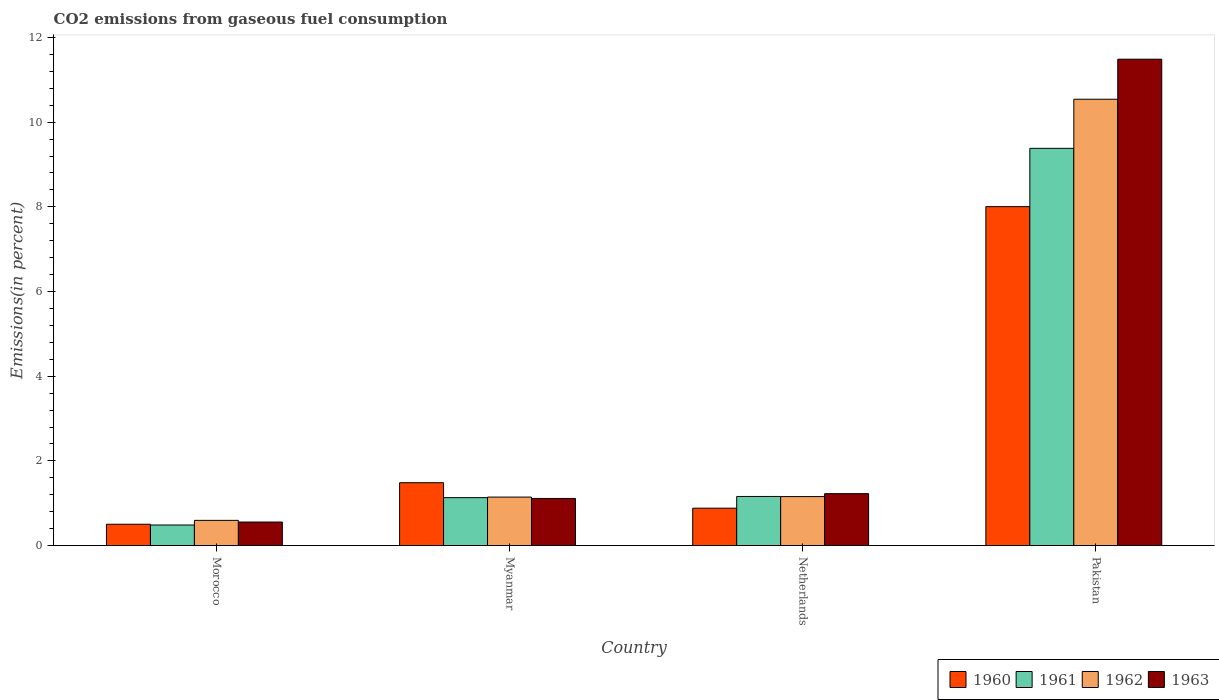How many different coloured bars are there?
Keep it short and to the point. 4. Are the number of bars per tick equal to the number of legend labels?
Keep it short and to the point. Yes. In how many cases, is the number of bars for a given country not equal to the number of legend labels?
Offer a very short reply. 0. What is the total CO2 emitted in 1962 in Pakistan?
Keep it short and to the point. 10.54. Across all countries, what is the maximum total CO2 emitted in 1963?
Give a very brief answer. 11.49. Across all countries, what is the minimum total CO2 emitted in 1963?
Offer a terse response. 0.56. In which country was the total CO2 emitted in 1960 maximum?
Offer a very short reply. Pakistan. In which country was the total CO2 emitted in 1960 minimum?
Your answer should be very brief. Morocco. What is the total total CO2 emitted in 1962 in the graph?
Your response must be concise. 13.44. What is the difference between the total CO2 emitted in 1960 in Myanmar and that in Netherlands?
Offer a very short reply. 0.6. What is the difference between the total CO2 emitted in 1961 in Myanmar and the total CO2 emitted in 1962 in Netherlands?
Ensure brevity in your answer.  -0.03. What is the average total CO2 emitted in 1963 per country?
Your answer should be compact. 3.6. What is the difference between the total CO2 emitted of/in 1962 and total CO2 emitted of/in 1960 in Morocco?
Provide a succinct answer. 0.09. In how many countries, is the total CO2 emitted in 1961 greater than 3.2 %?
Your response must be concise. 1. What is the ratio of the total CO2 emitted in 1962 in Morocco to that in Pakistan?
Offer a terse response. 0.06. Is the total CO2 emitted in 1960 in Myanmar less than that in Netherlands?
Your answer should be compact. No. Is the difference between the total CO2 emitted in 1962 in Myanmar and Netherlands greater than the difference between the total CO2 emitted in 1960 in Myanmar and Netherlands?
Provide a short and direct response. No. What is the difference between the highest and the second highest total CO2 emitted in 1961?
Ensure brevity in your answer.  8.25. What is the difference between the highest and the lowest total CO2 emitted in 1962?
Your answer should be very brief. 9.95. In how many countries, is the total CO2 emitted in 1962 greater than the average total CO2 emitted in 1962 taken over all countries?
Your response must be concise. 1. Is it the case that in every country, the sum of the total CO2 emitted in 1962 and total CO2 emitted in 1963 is greater than the total CO2 emitted in 1961?
Your answer should be compact. Yes. How many countries are there in the graph?
Provide a short and direct response. 4. Are the values on the major ticks of Y-axis written in scientific E-notation?
Provide a short and direct response. No. Where does the legend appear in the graph?
Offer a terse response. Bottom right. How are the legend labels stacked?
Your answer should be compact. Horizontal. What is the title of the graph?
Make the answer very short. CO2 emissions from gaseous fuel consumption. Does "1972" appear as one of the legend labels in the graph?
Ensure brevity in your answer.  No. What is the label or title of the X-axis?
Your response must be concise. Country. What is the label or title of the Y-axis?
Ensure brevity in your answer.  Emissions(in percent). What is the Emissions(in percent) in 1960 in Morocco?
Your response must be concise. 0.5. What is the Emissions(in percent) of 1961 in Morocco?
Keep it short and to the point. 0.49. What is the Emissions(in percent) in 1962 in Morocco?
Your response must be concise. 0.6. What is the Emissions(in percent) of 1963 in Morocco?
Make the answer very short. 0.56. What is the Emissions(in percent) in 1960 in Myanmar?
Ensure brevity in your answer.  1.48. What is the Emissions(in percent) of 1961 in Myanmar?
Keep it short and to the point. 1.13. What is the Emissions(in percent) in 1962 in Myanmar?
Offer a terse response. 1.15. What is the Emissions(in percent) in 1963 in Myanmar?
Offer a very short reply. 1.11. What is the Emissions(in percent) of 1960 in Netherlands?
Provide a short and direct response. 0.88. What is the Emissions(in percent) in 1961 in Netherlands?
Provide a succinct answer. 1.16. What is the Emissions(in percent) in 1962 in Netherlands?
Make the answer very short. 1.16. What is the Emissions(in percent) of 1963 in Netherlands?
Provide a short and direct response. 1.23. What is the Emissions(in percent) of 1960 in Pakistan?
Your answer should be compact. 8.01. What is the Emissions(in percent) in 1961 in Pakistan?
Offer a terse response. 9.38. What is the Emissions(in percent) of 1962 in Pakistan?
Your answer should be very brief. 10.54. What is the Emissions(in percent) of 1963 in Pakistan?
Offer a very short reply. 11.49. Across all countries, what is the maximum Emissions(in percent) of 1960?
Your response must be concise. 8.01. Across all countries, what is the maximum Emissions(in percent) in 1961?
Offer a terse response. 9.38. Across all countries, what is the maximum Emissions(in percent) in 1962?
Provide a short and direct response. 10.54. Across all countries, what is the maximum Emissions(in percent) of 1963?
Keep it short and to the point. 11.49. Across all countries, what is the minimum Emissions(in percent) in 1960?
Keep it short and to the point. 0.5. Across all countries, what is the minimum Emissions(in percent) in 1961?
Offer a very short reply. 0.49. Across all countries, what is the minimum Emissions(in percent) in 1962?
Your answer should be compact. 0.6. Across all countries, what is the minimum Emissions(in percent) of 1963?
Your response must be concise. 0.56. What is the total Emissions(in percent) in 1960 in the graph?
Your answer should be very brief. 10.88. What is the total Emissions(in percent) in 1961 in the graph?
Your answer should be very brief. 12.16. What is the total Emissions(in percent) in 1962 in the graph?
Keep it short and to the point. 13.44. What is the total Emissions(in percent) of 1963 in the graph?
Give a very brief answer. 14.38. What is the difference between the Emissions(in percent) in 1960 in Morocco and that in Myanmar?
Make the answer very short. -0.98. What is the difference between the Emissions(in percent) of 1961 in Morocco and that in Myanmar?
Provide a short and direct response. -0.65. What is the difference between the Emissions(in percent) in 1962 in Morocco and that in Myanmar?
Your answer should be very brief. -0.55. What is the difference between the Emissions(in percent) of 1963 in Morocco and that in Myanmar?
Make the answer very short. -0.56. What is the difference between the Emissions(in percent) in 1960 in Morocco and that in Netherlands?
Make the answer very short. -0.38. What is the difference between the Emissions(in percent) in 1961 in Morocco and that in Netherlands?
Provide a short and direct response. -0.67. What is the difference between the Emissions(in percent) in 1962 in Morocco and that in Netherlands?
Keep it short and to the point. -0.56. What is the difference between the Emissions(in percent) of 1963 in Morocco and that in Netherlands?
Your answer should be very brief. -0.67. What is the difference between the Emissions(in percent) of 1960 in Morocco and that in Pakistan?
Your answer should be very brief. -7.5. What is the difference between the Emissions(in percent) in 1961 in Morocco and that in Pakistan?
Provide a succinct answer. -8.9. What is the difference between the Emissions(in percent) of 1962 in Morocco and that in Pakistan?
Provide a short and direct response. -9.95. What is the difference between the Emissions(in percent) of 1963 in Morocco and that in Pakistan?
Make the answer very short. -10.93. What is the difference between the Emissions(in percent) of 1960 in Myanmar and that in Netherlands?
Offer a terse response. 0.6. What is the difference between the Emissions(in percent) in 1961 in Myanmar and that in Netherlands?
Offer a very short reply. -0.03. What is the difference between the Emissions(in percent) of 1962 in Myanmar and that in Netherlands?
Your answer should be compact. -0.01. What is the difference between the Emissions(in percent) of 1963 in Myanmar and that in Netherlands?
Your response must be concise. -0.11. What is the difference between the Emissions(in percent) of 1960 in Myanmar and that in Pakistan?
Make the answer very short. -6.52. What is the difference between the Emissions(in percent) of 1961 in Myanmar and that in Pakistan?
Your response must be concise. -8.25. What is the difference between the Emissions(in percent) in 1962 in Myanmar and that in Pakistan?
Make the answer very short. -9.4. What is the difference between the Emissions(in percent) of 1963 in Myanmar and that in Pakistan?
Your response must be concise. -10.37. What is the difference between the Emissions(in percent) in 1960 in Netherlands and that in Pakistan?
Offer a terse response. -7.12. What is the difference between the Emissions(in percent) of 1961 in Netherlands and that in Pakistan?
Your response must be concise. -8.22. What is the difference between the Emissions(in percent) in 1962 in Netherlands and that in Pakistan?
Give a very brief answer. -9.38. What is the difference between the Emissions(in percent) of 1963 in Netherlands and that in Pakistan?
Make the answer very short. -10.26. What is the difference between the Emissions(in percent) of 1960 in Morocco and the Emissions(in percent) of 1961 in Myanmar?
Make the answer very short. -0.63. What is the difference between the Emissions(in percent) of 1960 in Morocco and the Emissions(in percent) of 1962 in Myanmar?
Ensure brevity in your answer.  -0.64. What is the difference between the Emissions(in percent) of 1960 in Morocco and the Emissions(in percent) of 1963 in Myanmar?
Provide a succinct answer. -0.61. What is the difference between the Emissions(in percent) of 1961 in Morocco and the Emissions(in percent) of 1962 in Myanmar?
Your answer should be very brief. -0.66. What is the difference between the Emissions(in percent) in 1961 in Morocco and the Emissions(in percent) in 1963 in Myanmar?
Offer a terse response. -0.63. What is the difference between the Emissions(in percent) of 1962 in Morocco and the Emissions(in percent) of 1963 in Myanmar?
Make the answer very short. -0.52. What is the difference between the Emissions(in percent) in 1960 in Morocco and the Emissions(in percent) in 1961 in Netherlands?
Provide a succinct answer. -0.66. What is the difference between the Emissions(in percent) in 1960 in Morocco and the Emissions(in percent) in 1962 in Netherlands?
Provide a succinct answer. -0.65. What is the difference between the Emissions(in percent) in 1960 in Morocco and the Emissions(in percent) in 1963 in Netherlands?
Your answer should be compact. -0.72. What is the difference between the Emissions(in percent) in 1961 in Morocco and the Emissions(in percent) in 1962 in Netherlands?
Your answer should be very brief. -0.67. What is the difference between the Emissions(in percent) of 1961 in Morocco and the Emissions(in percent) of 1963 in Netherlands?
Keep it short and to the point. -0.74. What is the difference between the Emissions(in percent) of 1962 in Morocco and the Emissions(in percent) of 1963 in Netherlands?
Give a very brief answer. -0.63. What is the difference between the Emissions(in percent) of 1960 in Morocco and the Emissions(in percent) of 1961 in Pakistan?
Provide a short and direct response. -8.88. What is the difference between the Emissions(in percent) in 1960 in Morocco and the Emissions(in percent) in 1962 in Pakistan?
Give a very brief answer. -10.04. What is the difference between the Emissions(in percent) in 1960 in Morocco and the Emissions(in percent) in 1963 in Pakistan?
Your answer should be very brief. -10.98. What is the difference between the Emissions(in percent) in 1961 in Morocco and the Emissions(in percent) in 1962 in Pakistan?
Provide a succinct answer. -10.06. What is the difference between the Emissions(in percent) of 1961 in Morocco and the Emissions(in percent) of 1963 in Pakistan?
Offer a very short reply. -11. What is the difference between the Emissions(in percent) of 1962 in Morocco and the Emissions(in percent) of 1963 in Pakistan?
Offer a terse response. -10.89. What is the difference between the Emissions(in percent) in 1960 in Myanmar and the Emissions(in percent) in 1961 in Netherlands?
Provide a short and direct response. 0.32. What is the difference between the Emissions(in percent) of 1960 in Myanmar and the Emissions(in percent) of 1962 in Netherlands?
Your response must be concise. 0.33. What is the difference between the Emissions(in percent) in 1960 in Myanmar and the Emissions(in percent) in 1963 in Netherlands?
Give a very brief answer. 0.26. What is the difference between the Emissions(in percent) of 1961 in Myanmar and the Emissions(in percent) of 1962 in Netherlands?
Offer a terse response. -0.03. What is the difference between the Emissions(in percent) in 1961 in Myanmar and the Emissions(in percent) in 1963 in Netherlands?
Your response must be concise. -0.09. What is the difference between the Emissions(in percent) of 1962 in Myanmar and the Emissions(in percent) of 1963 in Netherlands?
Your answer should be compact. -0.08. What is the difference between the Emissions(in percent) of 1960 in Myanmar and the Emissions(in percent) of 1961 in Pakistan?
Provide a succinct answer. -7.9. What is the difference between the Emissions(in percent) of 1960 in Myanmar and the Emissions(in percent) of 1962 in Pakistan?
Provide a succinct answer. -9.06. What is the difference between the Emissions(in percent) of 1960 in Myanmar and the Emissions(in percent) of 1963 in Pakistan?
Offer a very short reply. -10. What is the difference between the Emissions(in percent) of 1961 in Myanmar and the Emissions(in percent) of 1962 in Pakistan?
Ensure brevity in your answer.  -9.41. What is the difference between the Emissions(in percent) of 1961 in Myanmar and the Emissions(in percent) of 1963 in Pakistan?
Provide a short and direct response. -10.36. What is the difference between the Emissions(in percent) of 1962 in Myanmar and the Emissions(in percent) of 1963 in Pakistan?
Offer a terse response. -10.34. What is the difference between the Emissions(in percent) in 1960 in Netherlands and the Emissions(in percent) in 1961 in Pakistan?
Keep it short and to the point. -8.5. What is the difference between the Emissions(in percent) in 1960 in Netherlands and the Emissions(in percent) in 1962 in Pakistan?
Offer a very short reply. -9.66. What is the difference between the Emissions(in percent) of 1960 in Netherlands and the Emissions(in percent) of 1963 in Pakistan?
Offer a terse response. -10.6. What is the difference between the Emissions(in percent) of 1961 in Netherlands and the Emissions(in percent) of 1962 in Pakistan?
Your answer should be compact. -9.38. What is the difference between the Emissions(in percent) of 1961 in Netherlands and the Emissions(in percent) of 1963 in Pakistan?
Make the answer very short. -10.33. What is the difference between the Emissions(in percent) in 1962 in Netherlands and the Emissions(in percent) in 1963 in Pakistan?
Keep it short and to the point. -10.33. What is the average Emissions(in percent) of 1960 per country?
Keep it short and to the point. 2.72. What is the average Emissions(in percent) of 1961 per country?
Give a very brief answer. 3.04. What is the average Emissions(in percent) of 1962 per country?
Provide a succinct answer. 3.36. What is the average Emissions(in percent) in 1963 per country?
Make the answer very short. 3.6. What is the difference between the Emissions(in percent) in 1960 and Emissions(in percent) in 1961 in Morocco?
Make the answer very short. 0.02. What is the difference between the Emissions(in percent) in 1960 and Emissions(in percent) in 1962 in Morocco?
Your answer should be compact. -0.09. What is the difference between the Emissions(in percent) in 1960 and Emissions(in percent) in 1963 in Morocco?
Ensure brevity in your answer.  -0.05. What is the difference between the Emissions(in percent) of 1961 and Emissions(in percent) of 1962 in Morocco?
Keep it short and to the point. -0.11. What is the difference between the Emissions(in percent) in 1961 and Emissions(in percent) in 1963 in Morocco?
Your response must be concise. -0.07. What is the difference between the Emissions(in percent) of 1962 and Emissions(in percent) of 1963 in Morocco?
Give a very brief answer. 0.04. What is the difference between the Emissions(in percent) in 1960 and Emissions(in percent) in 1961 in Myanmar?
Ensure brevity in your answer.  0.35. What is the difference between the Emissions(in percent) of 1960 and Emissions(in percent) of 1962 in Myanmar?
Your response must be concise. 0.34. What is the difference between the Emissions(in percent) of 1960 and Emissions(in percent) of 1963 in Myanmar?
Make the answer very short. 0.37. What is the difference between the Emissions(in percent) of 1961 and Emissions(in percent) of 1962 in Myanmar?
Your answer should be compact. -0.01. What is the difference between the Emissions(in percent) in 1961 and Emissions(in percent) in 1963 in Myanmar?
Offer a terse response. 0.02. What is the difference between the Emissions(in percent) in 1962 and Emissions(in percent) in 1963 in Myanmar?
Make the answer very short. 0.03. What is the difference between the Emissions(in percent) in 1960 and Emissions(in percent) in 1961 in Netherlands?
Provide a short and direct response. -0.28. What is the difference between the Emissions(in percent) in 1960 and Emissions(in percent) in 1962 in Netherlands?
Keep it short and to the point. -0.27. What is the difference between the Emissions(in percent) in 1960 and Emissions(in percent) in 1963 in Netherlands?
Give a very brief answer. -0.34. What is the difference between the Emissions(in percent) in 1961 and Emissions(in percent) in 1962 in Netherlands?
Your response must be concise. 0. What is the difference between the Emissions(in percent) of 1961 and Emissions(in percent) of 1963 in Netherlands?
Your response must be concise. -0.07. What is the difference between the Emissions(in percent) in 1962 and Emissions(in percent) in 1963 in Netherlands?
Provide a short and direct response. -0.07. What is the difference between the Emissions(in percent) of 1960 and Emissions(in percent) of 1961 in Pakistan?
Provide a short and direct response. -1.38. What is the difference between the Emissions(in percent) of 1960 and Emissions(in percent) of 1962 in Pakistan?
Ensure brevity in your answer.  -2.54. What is the difference between the Emissions(in percent) in 1960 and Emissions(in percent) in 1963 in Pakistan?
Ensure brevity in your answer.  -3.48. What is the difference between the Emissions(in percent) in 1961 and Emissions(in percent) in 1962 in Pakistan?
Your response must be concise. -1.16. What is the difference between the Emissions(in percent) of 1961 and Emissions(in percent) of 1963 in Pakistan?
Make the answer very short. -2.11. What is the difference between the Emissions(in percent) of 1962 and Emissions(in percent) of 1963 in Pakistan?
Provide a short and direct response. -0.95. What is the ratio of the Emissions(in percent) of 1960 in Morocco to that in Myanmar?
Your response must be concise. 0.34. What is the ratio of the Emissions(in percent) of 1961 in Morocco to that in Myanmar?
Provide a short and direct response. 0.43. What is the ratio of the Emissions(in percent) of 1962 in Morocco to that in Myanmar?
Provide a short and direct response. 0.52. What is the ratio of the Emissions(in percent) of 1963 in Morocco to that in Myanmar?
Provide a short and direct response. 0.5. What is the ratio of the Emissions(in percent) in 1960 in Morocco to that in Netherlands?
Give a very brief answer. 0.57. What is the ratio of the Emissions(in percent) in 1961 in Morocco to that in Netherlands?
Your answer should be compact. 0.42. What is the ratio of the Emissions(in percent) of 1962 in Morocco to that in Netherlands?
Provide a short and direct response. 0.51. What is the ratio of the Emissions(in percent) of 1963 in Morocco to that in Netherlands?
Offer a terse response. 0.45. What is the ratio of the Emissions(in percent) of 1960 in Morocco to that in Pakistan?
Your answer should be compact. 0.06. What is the ratio of the Emissions(in percent) in 1961 in Morocco to that in Pakistan?
Your answer should be compact. 0.05. What is the ratio of the Emissions(in percent) in 1962 in Morocco to that in Pakistan?
Your response must be concise. 0.06. What is the ratio of the Emissions(in percent) of 1963 in Morocco to that in Pakistan?
Provide a succinct answer. 0.05. What is the ratio of the Emissions(in percent) in 1960 in Myanmar to that in Netherlands?
Offer a terse response. 1.68. What is the ratio of the Emissions(in percent) in 1961 in Myanmar to that in Netherlands?
Your answer should be compact. 0.98. What is the ratio of the Emissions(in percent) in 1962 in Myanmar to that in Netherlands?
Give a very brief answer. 0.99. What is the ratio of the Emissions(in percent) of 1963 in Myanmar to that in Netherlands?
Your answer should be very brief. 0.91. What is the ratio of the Emissions(in percent) of 1960 in Myanmar to that in Pakistan?
Offer a terse response. 0.19. What is the ratio of the Emissions(in percent) of 1961 in Myanmar to that in Pakistan?
Your response must be concise. 0.12. What is the ratio of the Emissions(in percent) in 1962 in Myanmar to that in Pakistan?
Ensure brevity in your answer.  0.11. What is the ratio of the Emissions(in percent) of 1963 in Myanmar to that in Pakistan?
Keep it short and to the point. 0.1. What is the ratio of the Emissions(in percent) of 1960 in Netherlands to that in Pakistan?
Provide a succinct answer. 0.11. What is the ratio of the Emissions(in percent) of 1961 in Netherlands to that in Pakistan?
Make the answer very short. 0.12. What is the ratio of the Emissions(in percent) in 1962 in Netherlands to that in Pakistan?
Your answer should be compact. 0.11. What is the ratio of the Emissions(in percent) in 1963 in Netherlands to that in Pakistan?
Make the answer very short. 0.11. What is the difference between the highest and the second highest Emissions(in percent) of 1960?
Provide a succinct answer. 6.52. What is the difference between the highest and the second highest Emissions(in percent) of 1961?
Offer a terse response. 8.22. What is the difference between the highest and the second highest Emissions(in percent) of 1962?
Your response must be concise. 9.38. What is the difference between the highest and the second highest Emissions(in percent) of 1963?
Offer a terse response. 10.26. What is the difference between the highest and the lowest Emissions(in percent) in 1960?
Provide a succinct answer. 7.5. What is the difference between the highest and the lowest Emissions(in percent) in 1961?
Make the answer very short. 8.9. What is the difference between the highest and the lowest Emissions(in percent) of 1962?
Provide a short and direct response. 9.95. What is the difference between the highest and the lowest Emissions(in percent) of 1963?
Your response must be concise. 10.93. 